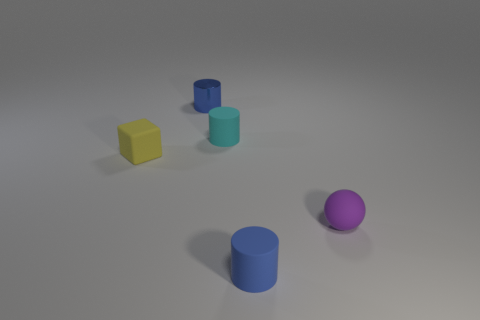Do the matte object that is behind the tiny rubber block and the purple matte object have the same shape?
Your answer should be compact. No. Is the number of tiny blue matte objects that are to the right of the small yellow matte cube greater than the number of large red metallic cylinders?
Keep it short and to the point. Yes. There is a shiny object that is the same size as the matte cube; what color is it?
Offer a terse response. Blue. What number of objects are rubber cylinders in front of the yellow matte block or blue matte blocks?
Your response must be concise. 1. There is a tiny blue thing behind the blue cylinder that is in front of the tiny purple sphere; what is its material?
Ensure brevity in your answer.  Metal. Are there any purple things that have the same material as the yellow block?
Provide a succinct answer. Yes. There is a rubber cylinder that is in front of the small purple sphere; is there a purple matte sphere in front of it?
Your answer should be compact. No. There is a yellow object that is behind the tiny purple rubber sphere; what material is it?
Your answer should be compact. Rubber. Does the small cyan rubber object have the same shape as the tiny yellow rubber object?
Provide a succinct answer. No. There is a small rubber thing that is in front of the small thing on the right side of the blue thing right of the tiny blue shiny thing; what is its color?
Offer a very short reply. Blue. 